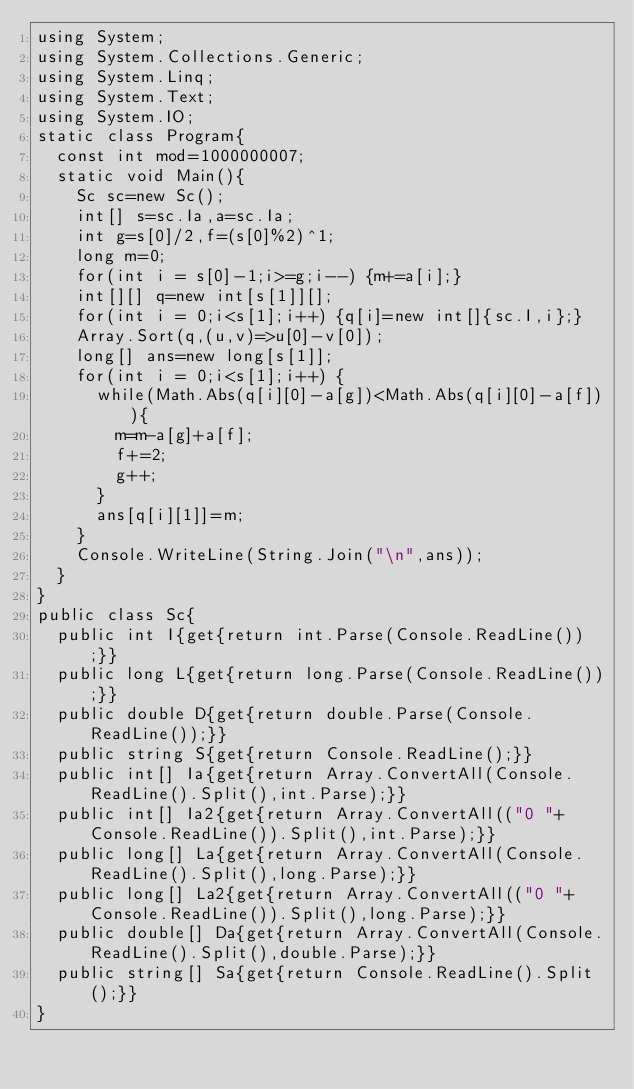Convert code to text. <code><loc_0><loc_0><loc_500><loc_500><_C#_>using System;
using System.Collections.Generic;
using System.Linq;
using System.Text;
using System.IO;
static class Program{
	const int mod=1000000007;
	static void Main(){
		Sc sc=new Sc();
		int[] s=sc.Ia,a=sc.Ia;
		int g=s[0]/2,f=(s[0]%2)^1;
		long m=0;
		for(int i = s[0]-1;i>=g;i--) {m+=a[i];}
		int[][] q=new int[s[1]][];
		for(int i = 0;i<s[1];i++) {q[i]=new int[]{sc.I,i};}
		Array.Sort(q,(u,v)=>u[0]-v[0]);
		long[] ans=new long[s[1]];
		for(int i = 0;i<s[1];i++) {
			while(Math.Abs(q[i][0]-a[g])<Math.Abs(q[i][0]-a[f])){
				m=m-a[g]+a[f];
				f+=2;
				g++;
			}
			ans[q[i][1]]=m;
		}
		Console.WriteLine(String.Join("\n",ans));
	}
}
public class Sc{
	public int I{get{return int.Parse(Console.ReadLine());}}
	public long L{get{return long.Parse(Console.ReadLine());}}
	public double D{get{return double.Parse(Console.ReadLine());}}
	public string S{get{return Console.ReadLine();}}
	public int[] Ia{get{return Array.ConvertAll(Console.ReadLine().Split(),int.Parse);}}
	public int[] Ia2{get{return Array.ConvertAll(("0 "+Console.ReadLine()).Split(),int.Parse);}}
	public long[] La{get{return Array.ConvertAll(Console.ReadLine().Split(),long.Parse);}}
	public long[] La2{get{return Array.ConvertAll(("0 "+Console.ReadLine()).Split(),long.Parse);}}
	public double[] Da{get{return Array.ConvertAll(Console.ReadLine().Split(),double.Parse);}}
	public string[] Sa{get{return Console.ReadLine().Split();}}
}</code> 